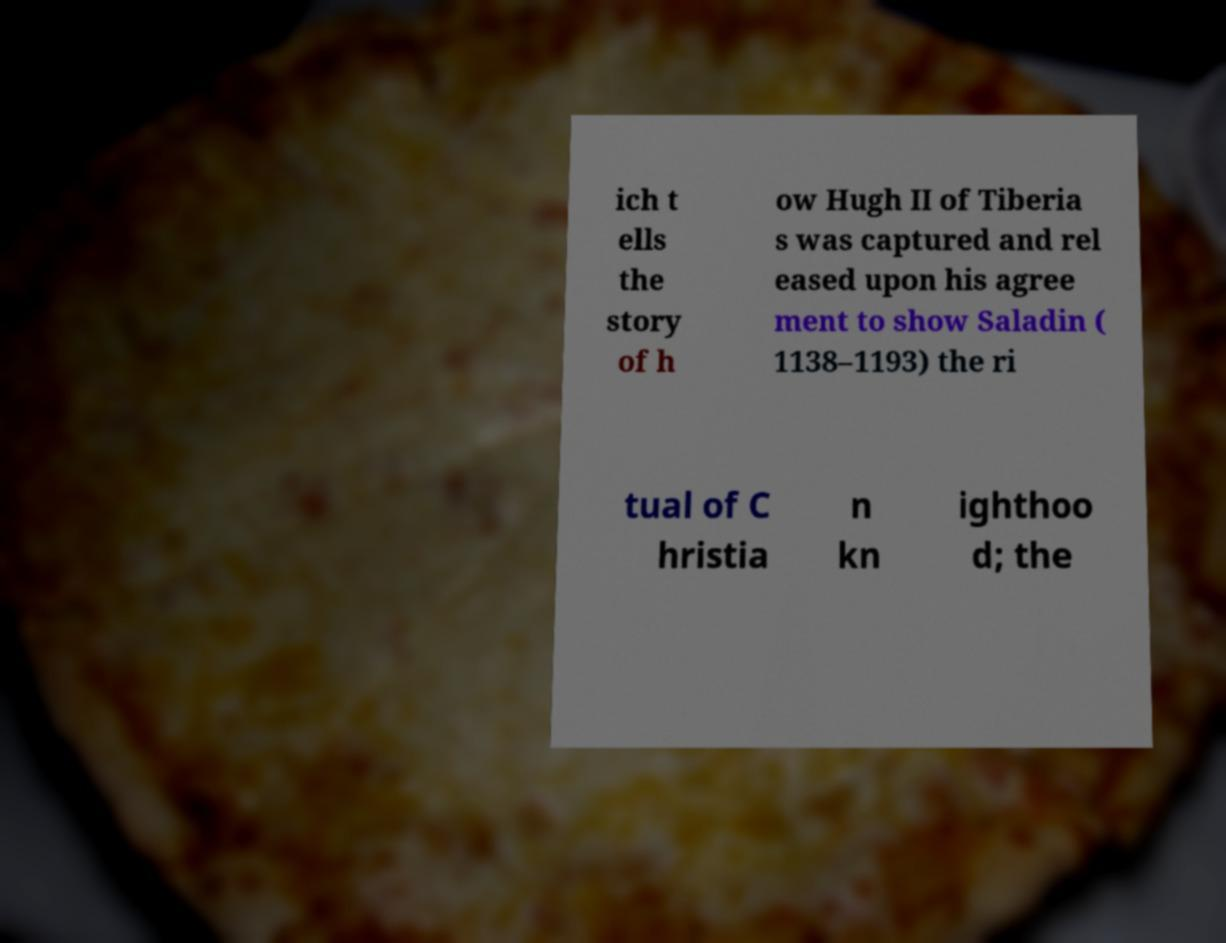Please read and relay the text visible in this image. What does it say? ich t ells the story of h ow Hugh II of Tiberia s was captured and rel eased upon his agree ment to show Saladin ( 1138–1193) the ri tual of C hristia n kn ighthoo d; the 